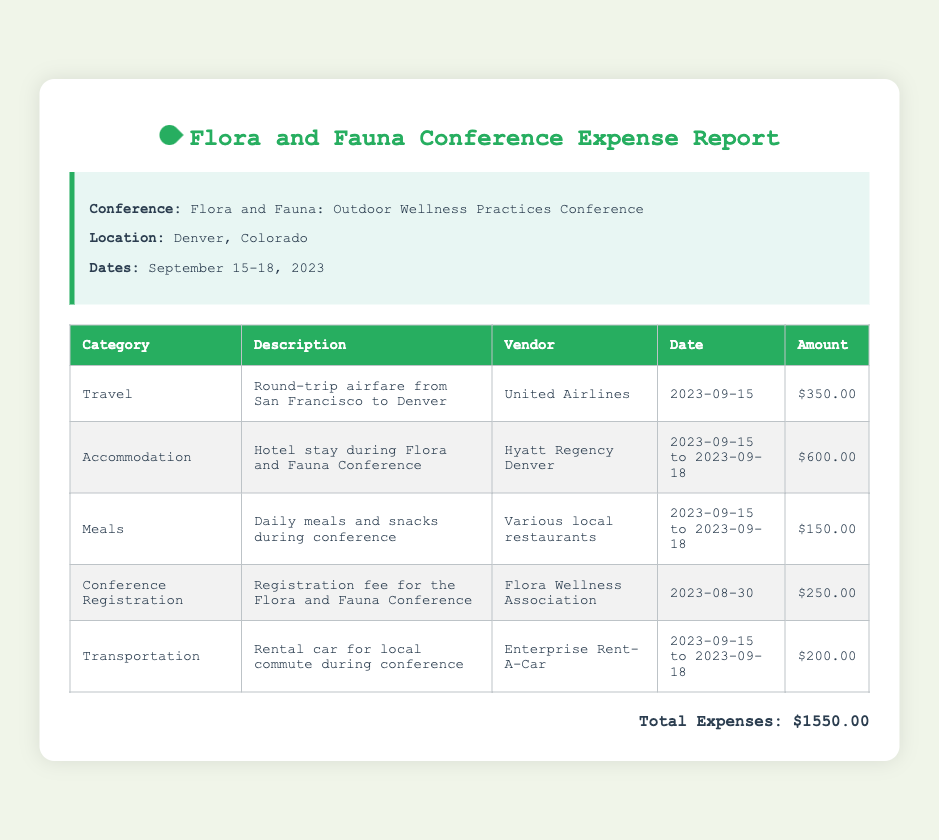what is the conference title? The conference title is specified in the document as "Flora and Fauna: Outdoor Wellness Practices Conference."
Answer: Flora and Fauna: Outdoor Wellness Practices Conference what is the location of the conference? The location of the conference is denoted in the document as Denver, Colorado.
Answer: Denver, Colorado what are the conference dates? The dates of the conference are mentioned clearly in the document as September 15-18, 2023.
Answer: September 15-18, 2023 how much was spent on accommodation? The accommodation expense is detailed in the table as $600.00 for the hotel stay during the conference.
Answer: $600.00 what was the total expense reported? The total expenses are summarized at the end of the document and are stated as $1550.00.
Answer: $1550.00 which vendor provided the airfare? The document lists United Airlines as the vendor for the airfare.
Answer: United Airlines how long was the hotel stay? The hotel stay duration is indicated as from 2023-09-15 to 2023-09-18.
Answer: 2023-09-15 to 2023-09-18 what type of transportation was rented? The document specifies that a rental car was used for local commute during the conference.
Answer: Rental car when was the registration fee paid? The registration fee date is mentioned as 2023-08-30 in the document.
Answer: 2023-08-30 